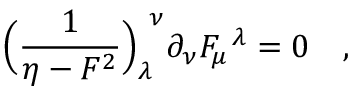Convert formula to latex. <formula><loc_0><loc_0><loc_500><loc_500>\left ( { \frac { 1 } { \eta - F ^ { 2 } } } \right ) _ { \lambda } ^ { \ \nu } \partial _ { \nu } F _ { \mu } ^ { \ \lambda } = 0 \quad ,</formula> 